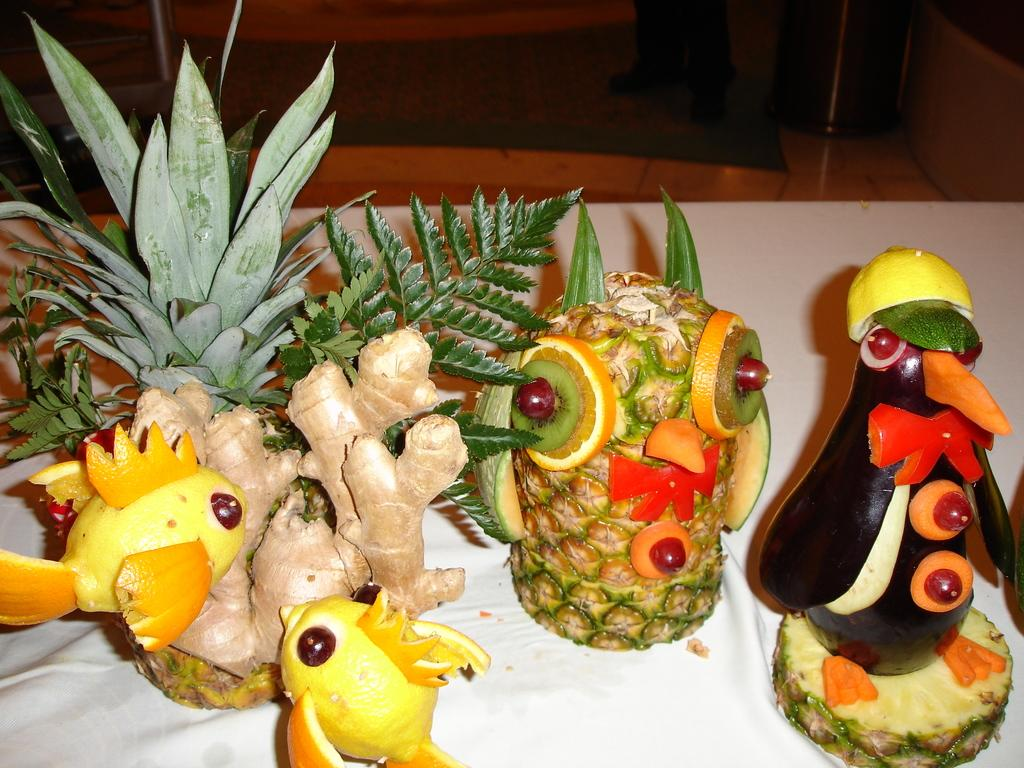What type of materials are used to create the crafts in the image? The crafts in the image are made of vegetables and fruits. Can you describe the different types of crafts that can be seen in the image? The image features crafts made of vegetables and fruits, but specific details about the crafts cannot be determined without additional information. What type of snails can be seen crawling on the moon in the image? There is no moon or snails present in the image; it features crafts made of vegetables and fruits. 